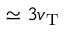Convert formula to latex. <formula><loc_0><loc_0><loc_500><loc_500>\simeq 3 v _ { T }</formula> 